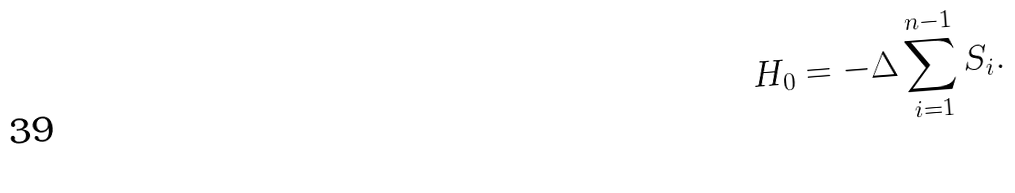<formula> <loc_0><loc_0><loc_500><loc_500>H _ { 0 } = - \Delta \sum _ { i = 1 } ^ { n - 1 } S _ { i } .</formula> 